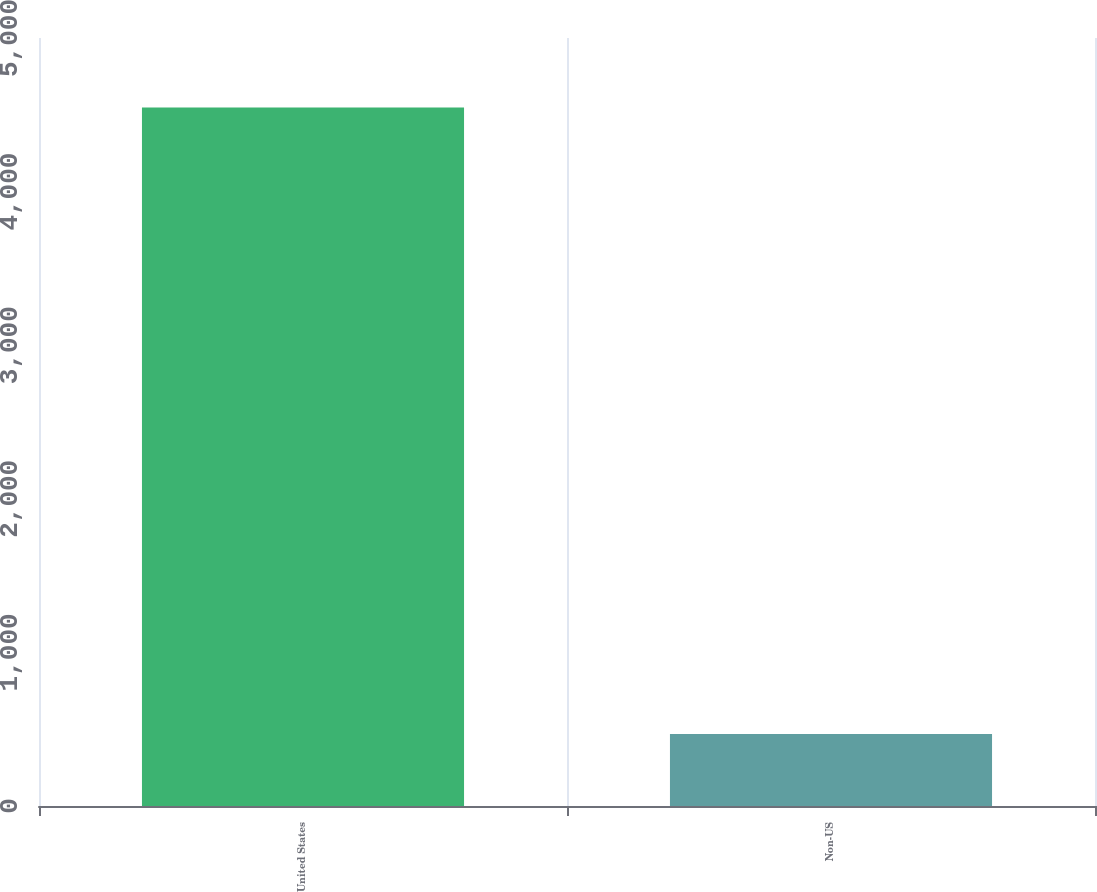Convert chart to OTSL. <chart><loc_0><loc_0><loc_500><loc_500><bar_chart><fcel>United States<fcel>Non-US<nl><fcel>4547<fcel>468<nl></chart> 